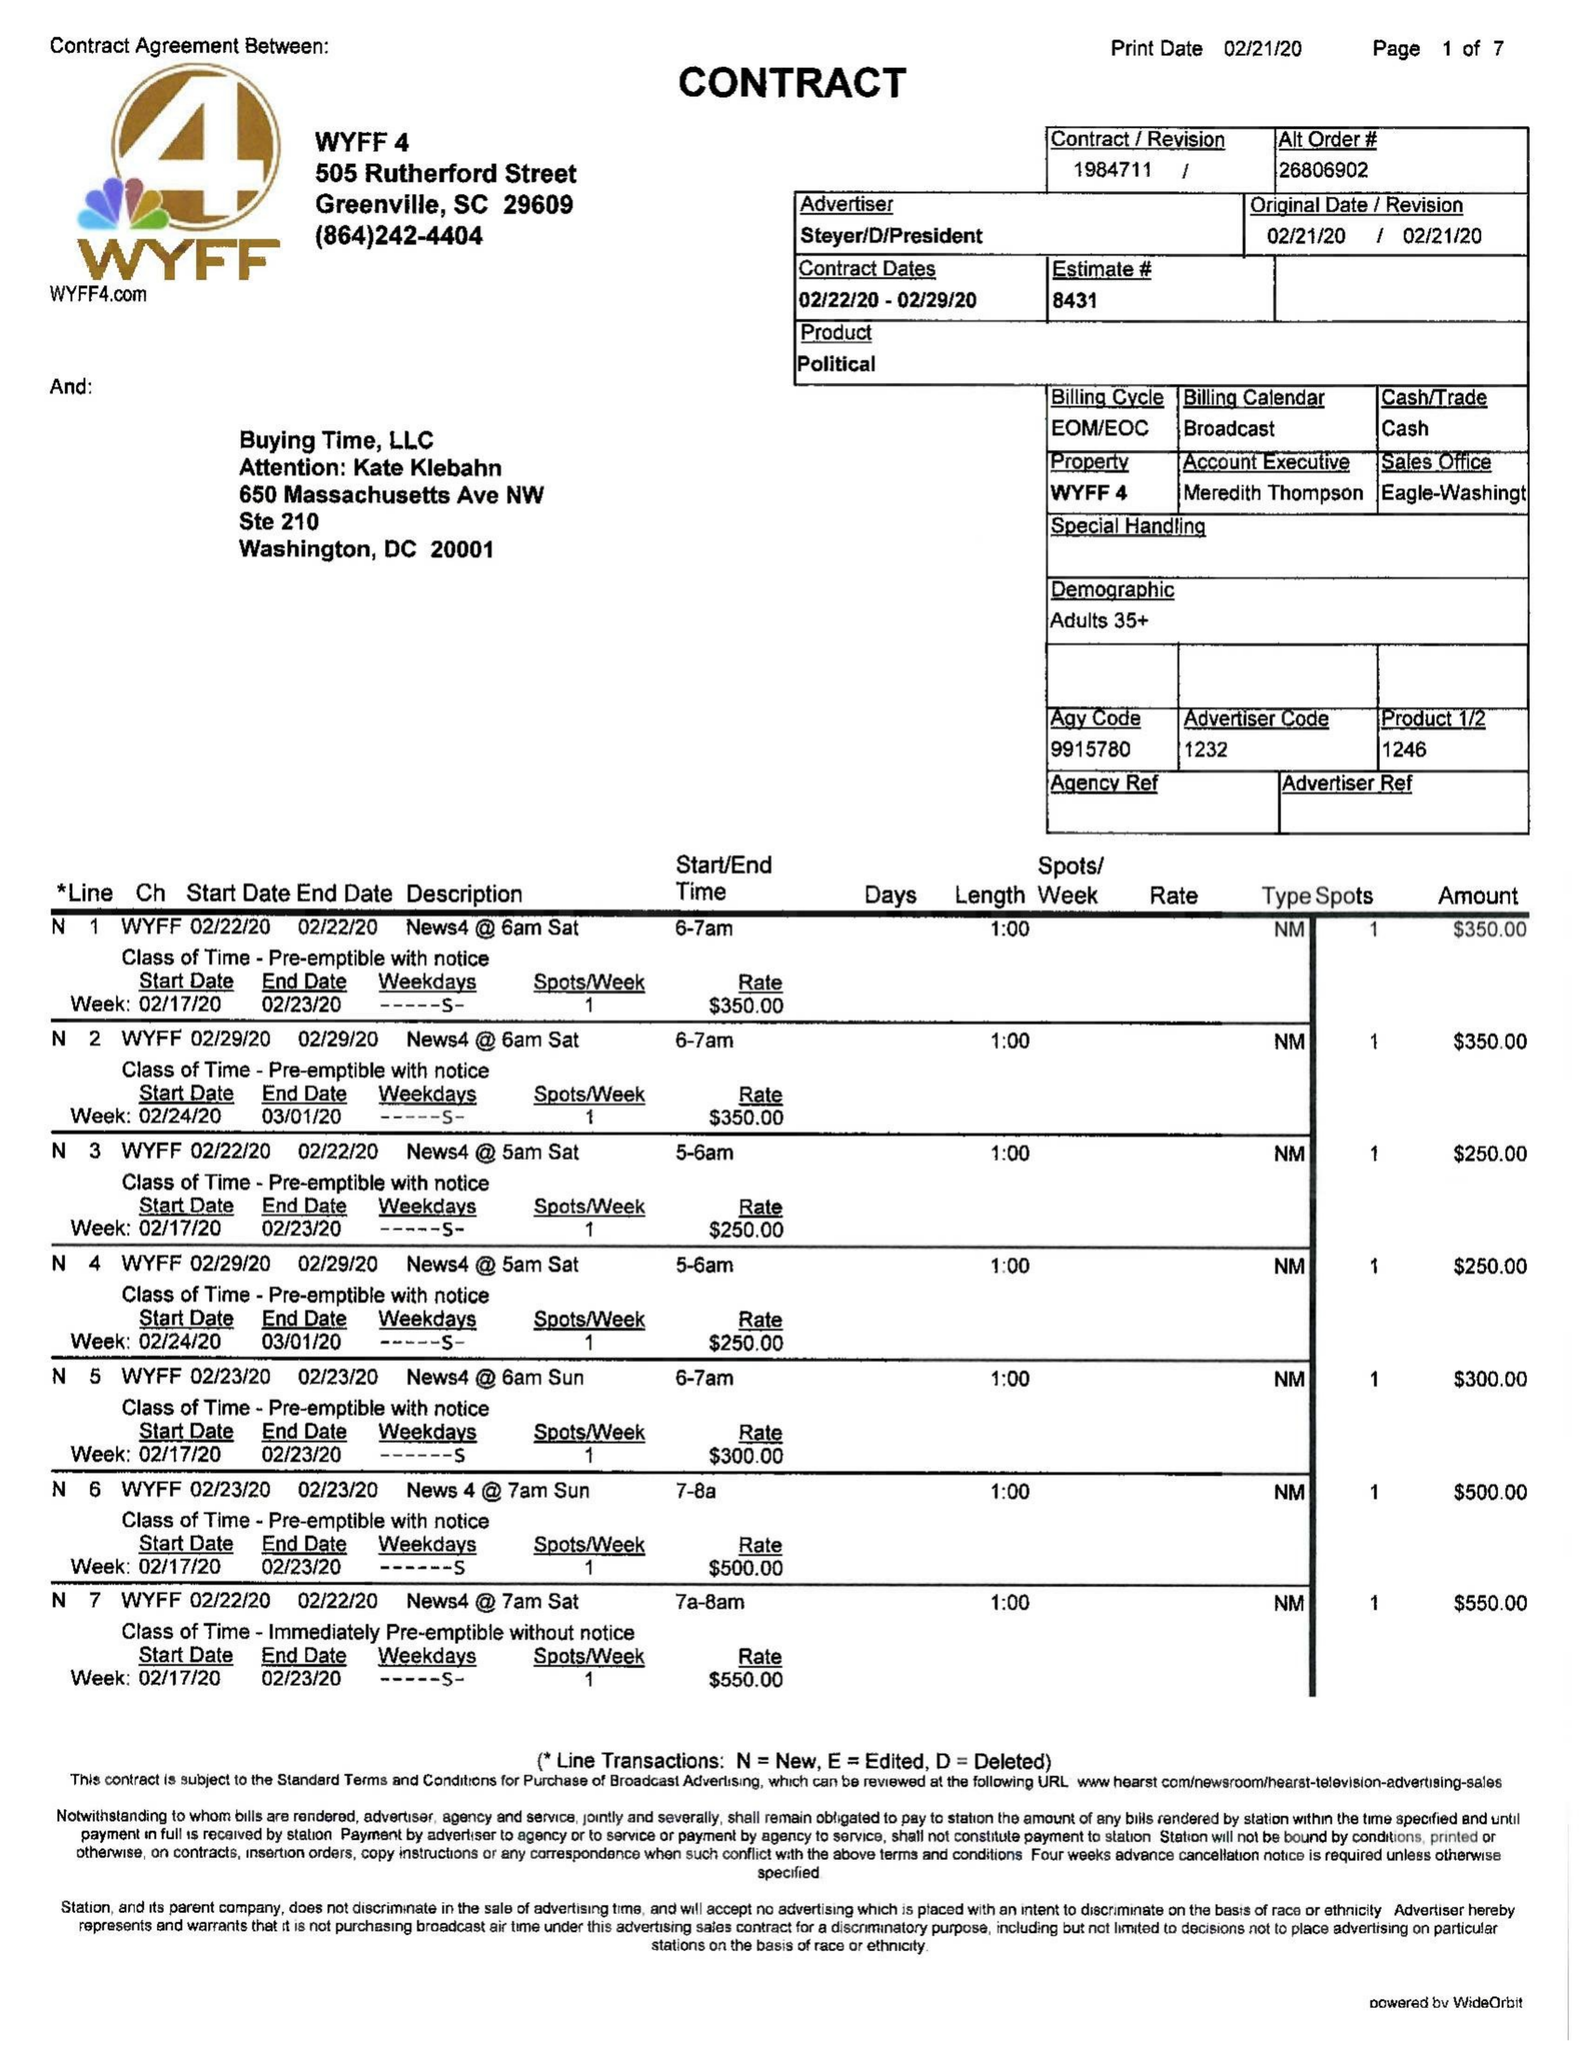What is the value for the contract_num?
Answer the question using a single word or phrase. 1984711 